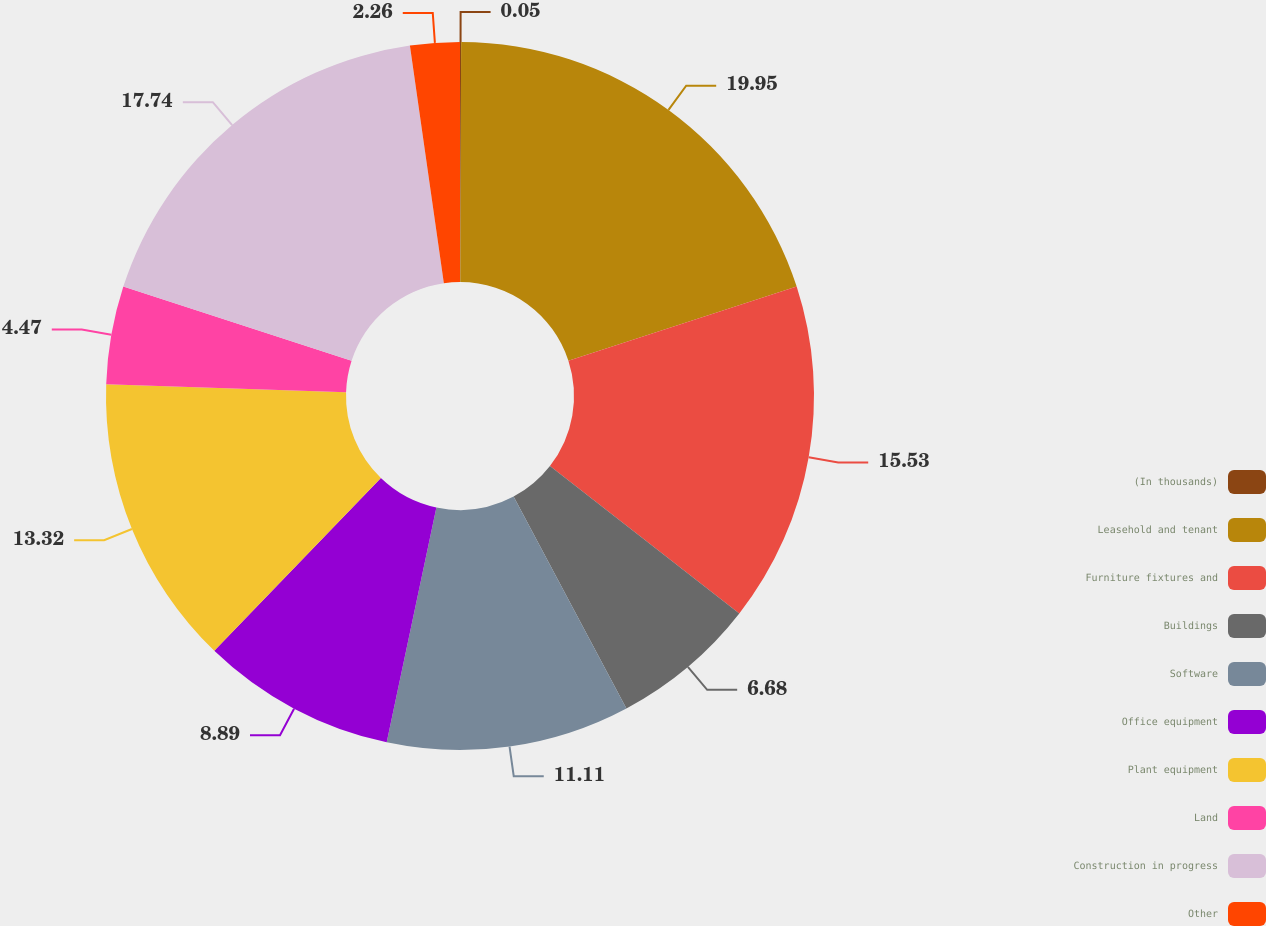Convert chart to OTSL. <chart><loc_0><loc_0><loc_500><loc_500><pie_chart><fcel>(In thousands)<fcel>Leasehold and tenant<fcel>Furniture fixtures and<fcel>Buildings<fcel>Software<fcel>Office equipment<fcel>Plant equipment<fcel>Land<fcel>Construction in progress<fcel>Other<nl><fcel>0.05%<fcel>19.95%<fcel>15.53%<fcel>6.68%<fcel>11.11%<fcel>8.89%<fcel>13.32%<fcel>4.47%<fcel>17.74%<fcel>2.26%<nl></chart> 